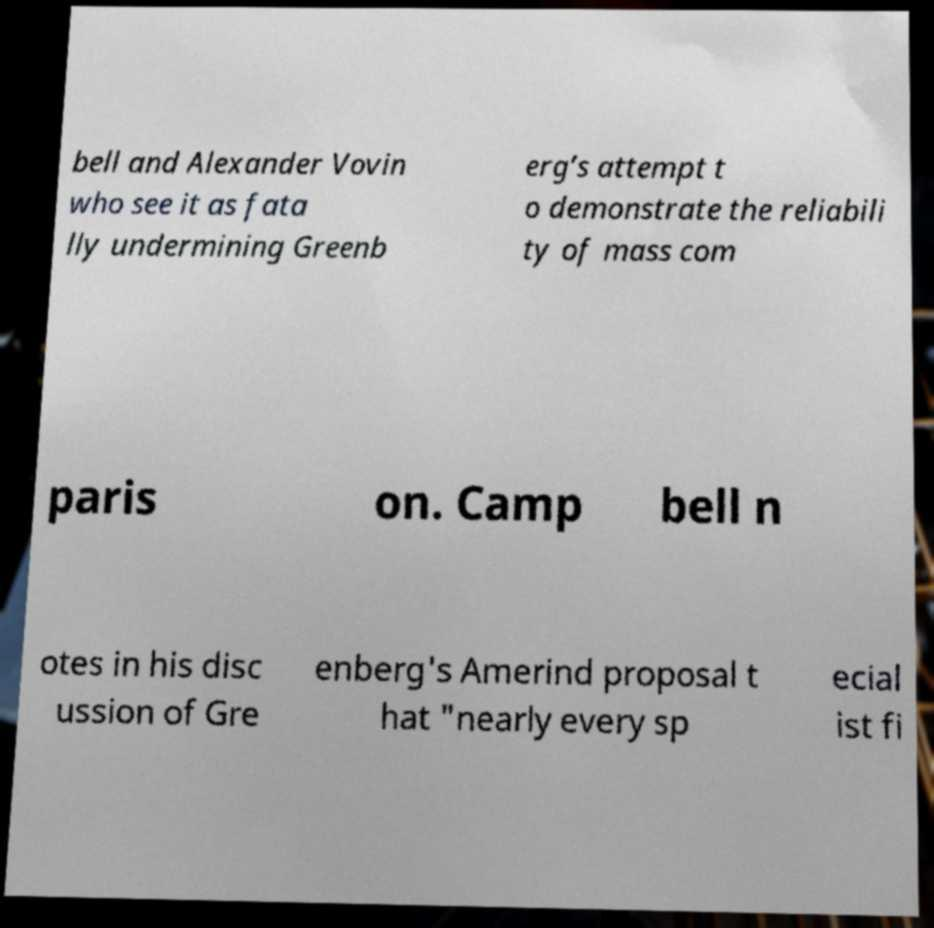Please identify and transcribe the text found in this image. bell and Alexander Vovin who see it as fata lly undermining Greenb erg’s attempt t o demonstrate the reliabili ty of mass com paris on. Camp bell n otes in his disc ussion of Gre enberg's Amerind proposal t hat "nearly every sp ecial ist fi 